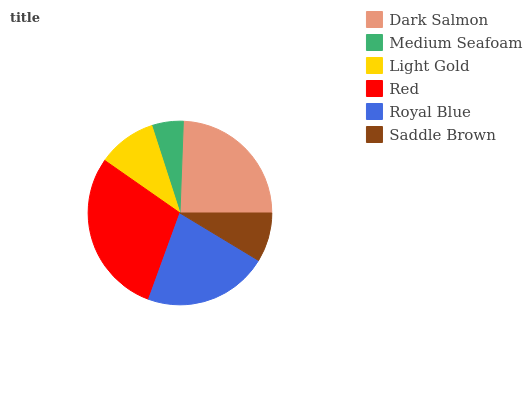Is Medium Seafoam the minimum?
Answer yes or no. Yes. Is Red the maximum?
Answer yes or no. Yes. Is Light Gold the minimum?
Answer yes or no. No. Is Light Gold the maximum?
Answer yes or no. No. Is Light Gold greater than Medium Seafoam?
Answer yes or no. Yes. Is Medium Seafoam less than Light Gold?
Answer yes or no. Yes. Is Medium Seafoam greater than Light Gold?
Answer yes or no. No. Is Light Gold less than Medium Seafoam?
Answer yes or no. No. Is Royal Blue the high median?
Answer yes or no. Yes. Is Light Gold the low median?
Answer yes or no. Yes. Is Red the high median?
Answer yes or no. No. Is Saddle Brown the low median?
Answer yes or no. No. 